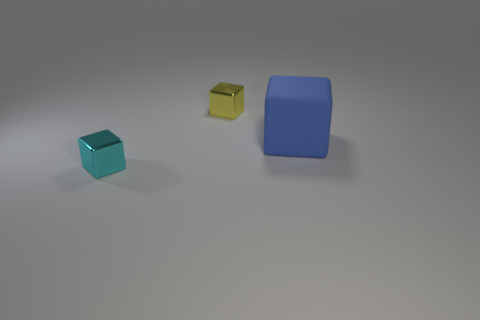Subtract all large blocks. How many blocks are left? 2 Add 3 purple metallic cubes. How many objects exist? 6 Subtract all yellow blocks. How many blocks are left? 2 Subtract 2 cubes. How many cubes are left? 1 Subtract 0 brown cylinders. How many objects are left? 3 Subtract all gray blocks. Subtract all cyan spheres. How many blocks are left? 3 Subtract all tiny cyan metal cubes. Subtract all tiny red balls. How many objects are left? 2 Add 3 small metallic things. How many small metallic things are left? 5 Add 3 large objects. How many large objects exist? 4 